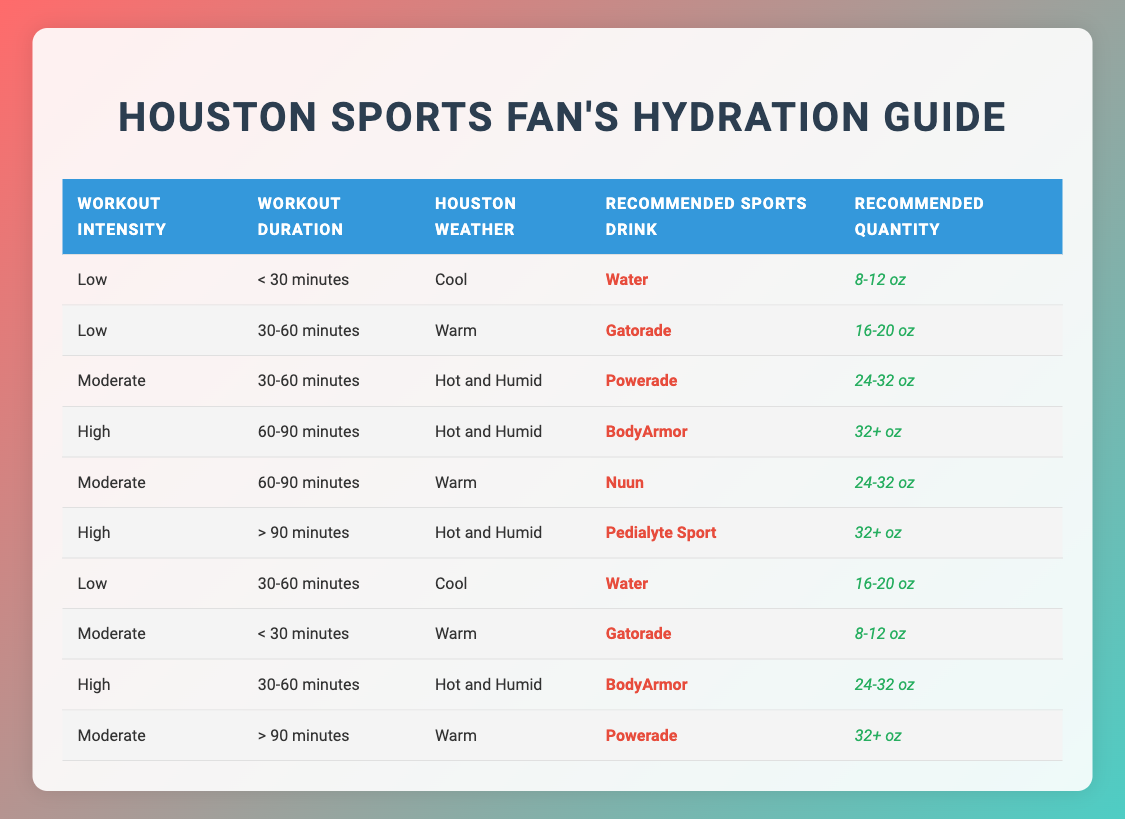What sports drink is recommended for a high-intensity workout lasting 60-90 minutes in hot and humid weather? According to the table, for a high-intensity workout lasting 60-90 minutes in hot and humid weather, the recommended sports drink is BodyArmor. This can be found by locating the row in the table where the conditions match "High" for workout intensity, "60-90 minutes" for duration, and "Hot and Humid" for weather.
Answer: BodyArmor How much of a sports drink is suggested for a moderate workout lasting over 90 minutes in warm weather? The table indicates for a moderate workout lasting over 90 minutes in warm weather, the recommended sports drink is Powerade, and the suggested quantity is 32+ oz. This is determined by finding the corresponding row with "Moderate," "> 90 minutes," and "Warm."
Answer: 32+ oz Is Gatorade recommended for low-intensity workouts lasting 30-60 minutes in cool weather? Yes, the table shows that Gatorade is recommended for low-intensity workouts lasting 30-60 minutes in warm weather, but it is also recommended if the workout is low-intensity for 30-60 minutes in cool weather too with a quantity of 16-20 oz. Thus, the statement is true.
Answer: Yes What drink should you choose for a high-intensity workout lasting less than 30 minutes in cool conditions? The table does not provide a specific recommendation for high-intensity workouts less than 30 minutes in cool weather. Instead, it shows that for low-intensity workouts in this time frame, water is recommended. Therefore, there is no specific drink for high intensity in this case.
Answer: No If I have a moderate intensity workout for 30-60 minutes in hot and humid weather, what sports drink and quantity should I consume? The table suggests Powerade for a moderate workout lasting 30-60 minutes in hot and humid weather, with a recommended quantity of 24-32 oz. This is verified by locating the appropriate row in the table for those conditions.
Answer: Powerade, 24-32 oz How many different recommended drinks are there for low-intensity workouts? There are two recommended drinks for low-intensity workouts: Water and Gatorade. This can be confirmed by reviewing all rows in the table and filtering based on "Low" workout intensity to count unique drink recommendations.
Answer: 2 What is the average recommended quantity for a moderate workout in warm weather? The recommended quantities for moderate workouts in warm weather listed in the table are 24-32 oz (Nuun for 60-90 minutes) and 32+ oz (Powerade for > 90 minutes). To find the average, the quantities can be treated as 28 oz and 32 oz; thus, (28 + 32) / 2 = 30 oz.
Answer: 30 oz Is Pedialyte Sport recommended for any low-intensity workouts? No, the table shows that Pedialyte Sport is only recommended for high-intensity workouts lasting over 90 minutes in hot and humid weather, indicating it is not suitable for low-intensity workouts.
Answer: No 